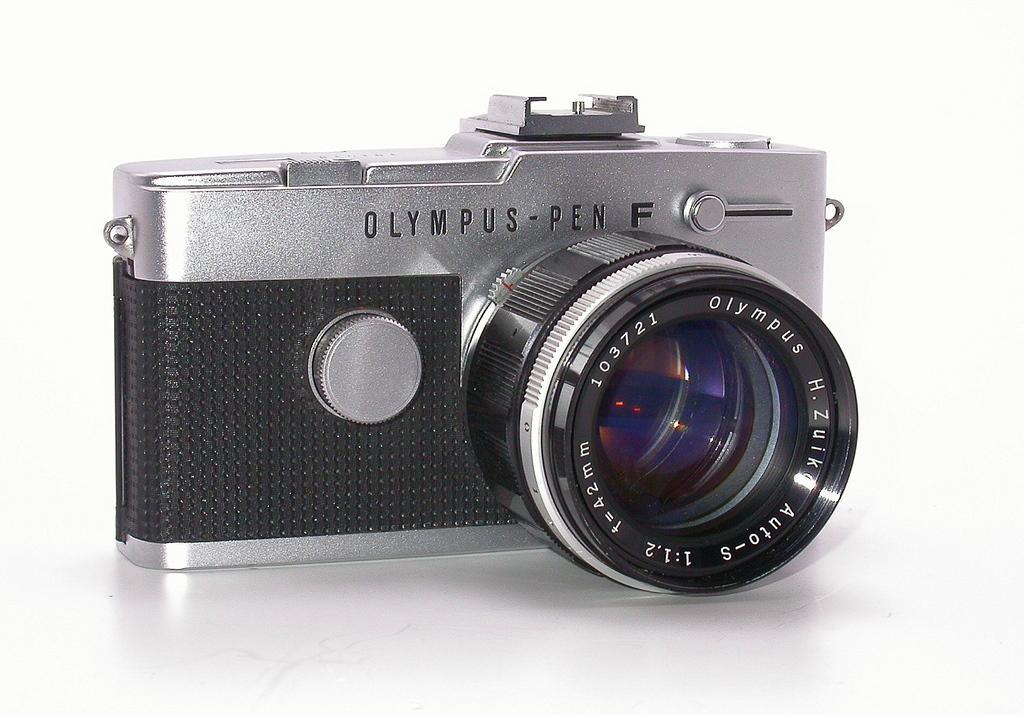Describe this image in one or two sentences. In the middle of the image there is a camera on the white surface. The camera is gray and black in colors. There is a text on the camera. 